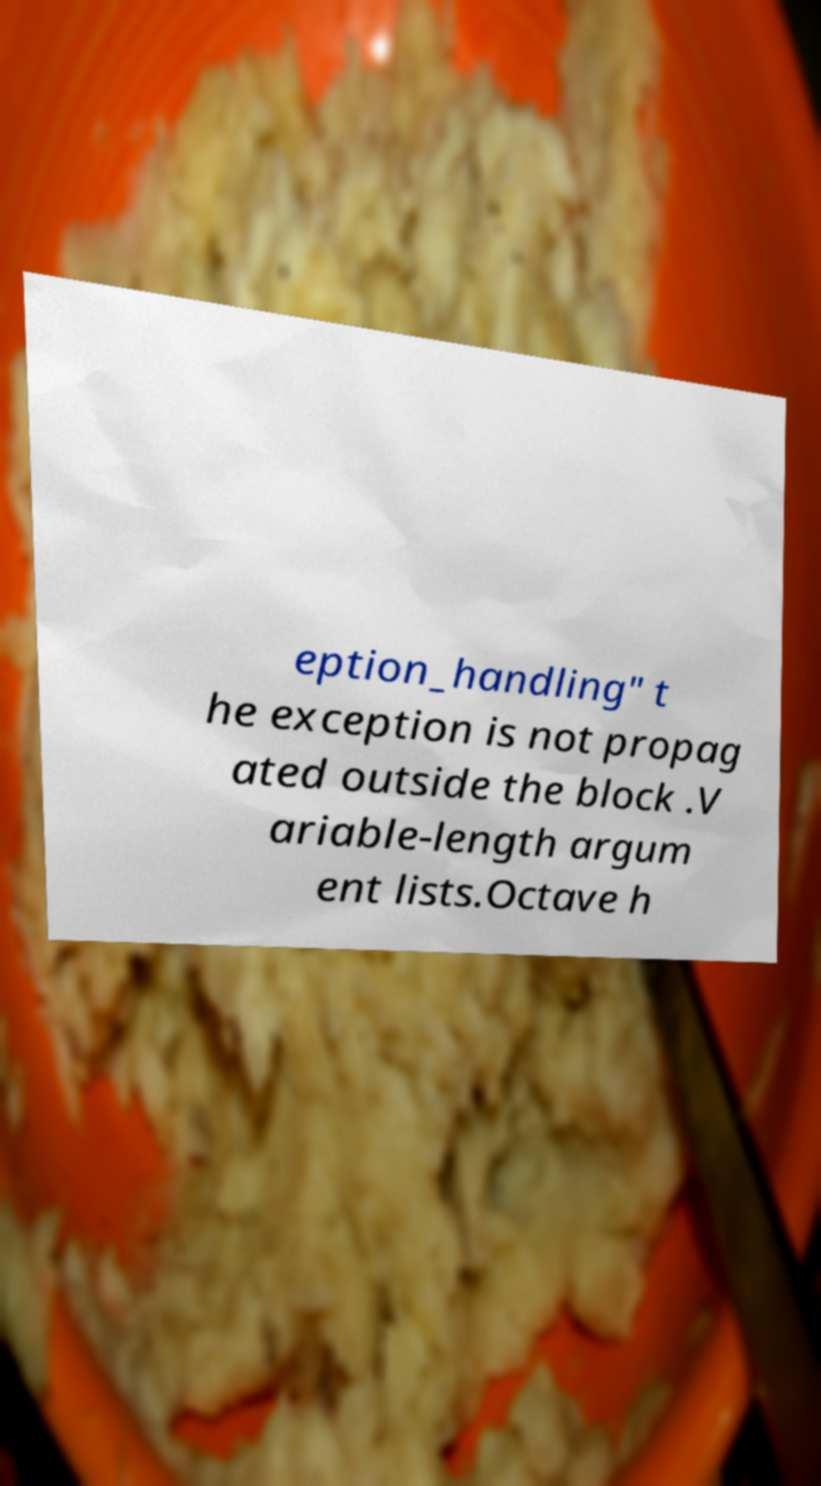Please identify and transcribe the text found in this image. eption_handling" t he exception is not propag ated outside the block .V ariable-length argum ent lists.Octave h 